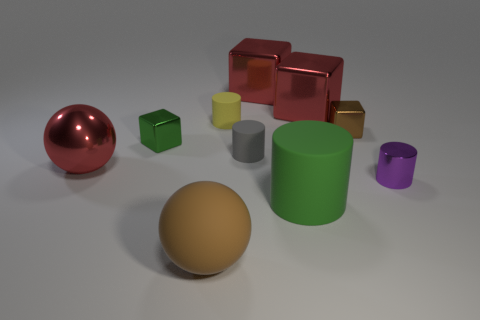Subtract all large matte cylinders. How many cylinders are left? 3 Subtract all yellow spheres. How many red cubes are left? 2 Subtract all green cubes. How many cubes are left? 3 Subtract 1 cylinders. How many cylinders are left? 3 Subtract all balls. How many objects are left? 8 Subtract 1 purple cylinders. How many objects are left? 9 Subtract all cyan cylinders. Subtract all purple blocks. How many cylinders are left? 4 Subtract all big red rubber things. Subtract all small brown metallic things. How many objects are left? 9 Add 3 rubber balls. How many rubber balls are left? 4 Add 9 big yellow rubber things. How many big yellow rubber things exist? 9 